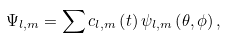Convert formula to latex. <formula><loc_0><loc_0><loc_500><loc_500>\Psi _ { l , m } = \sum c _ { l , m } \left ( t \right ) \psi _ { l , m } \left ( \theta , \phi \right ) ,</formula> 